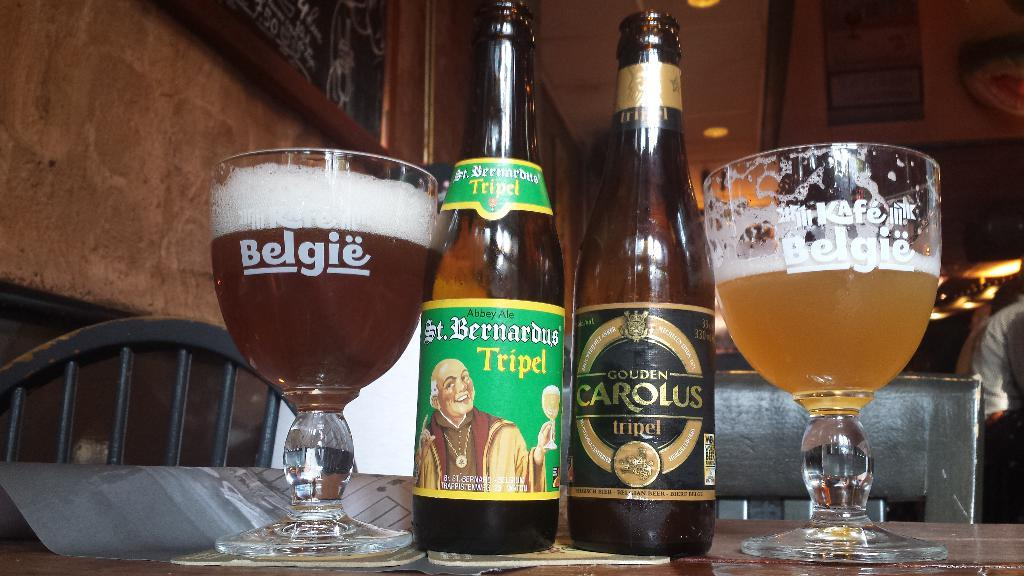Provide a one-sentence caption for the provided image. A glass full of beer reads Belgie on the side. 